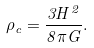<formula> <loc_0><loc_0><loc_500><loc_500>\rho _ { c } = \frac { 3 H ^ { 2 } } { 8 \pi G } .</formula> 